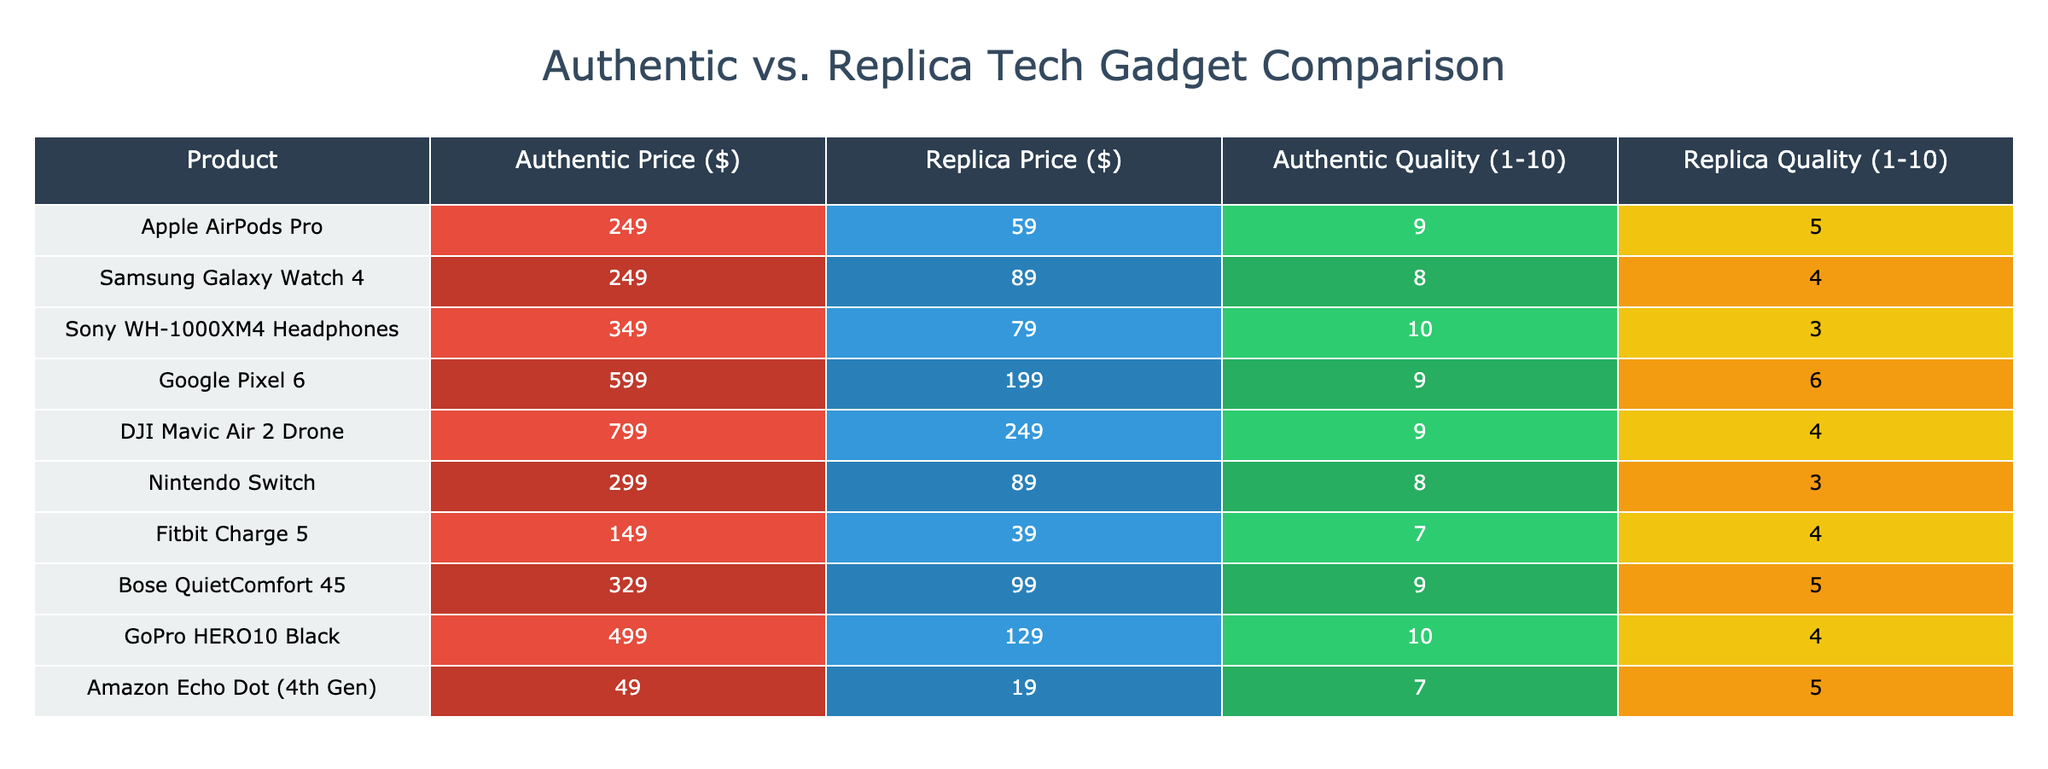What is the price difference between the authentic and replica Apple AirPods Pro? The authentic price is $249 and the replica price is $59. The difference is calculated as $249 - $59 = $190.
Answer: 190 Which product has the highest quality rating for the authentic version? The Sony WH-1000XM4 Headphones have the highest quality rating of 10 on the authentic scale.
Answer: Sony WH-1000XM4 Headphones Is the quality of the replica Google Pixel 6 better than that of the replica Fitbit Charge 5? The replica quality of Google Pixel 6 is rated 6, while the Fitbit Charge 5 is rated 4. Since 6 is greater than 4, the Google Pixel 6 has better quality than the Fitbit Charge 5.
Answer: Yes What is the average authentic price of all the products listed? To calculate the average, sum the authentic prices: 249 + 249 + 349 + 599 + 799 + 299 + 149 + 329 + 499 + 49 = 2,670. There are 10 products, so the average is 2,670 / 10 = 267.
Answer: 267 Are there any products where the authentic price is less than twice the replica price? To find this, we need to check each product's prices. Checking each pair: Apple AirPods Pro (249 vs 59), Samsung Galaxy Watch 4 (249 vs 89), Sony WH-1000XM4 (349 vs 79), Google Pixel 6 (599 vs 199), DJI Mavic Air 2 (799 vs 249), Nintendo Switch (299 vs 89), Fitbit Charge 5 (149 vs 39), Bose QuietComfort 45 (329 vs 99), GoPro HERO10 Black (499 vs 129), Amazon Echo Dot (49 vs 19). None meet the criteria where authentic is less than twice the replica, as all authentic prices are either equal to or more than double their replica counterpart.
Answer: No What is the total quality score for all the replica gadgets? Summing the replica quality scores gives: 5 + 4 + 3 + 6 + 4 + 3 + 4 + 5 + 4 + 5 = 43.
Answer: 43 Which authentic gadget has the lowest quality rating? Looking through the quality ratings for the authentic gadgets, the Nintendo Switch has the lowest rating of 8.
Answer: Nintendo Switch What percentage of the authentic products have a quality score of 9 or higher? There are 10 authentic products, and 5 of them have a quality score of 9 or above (Apple AirPods Pro, Sony WH-1000XM4, Google Pixel 6, Bose QuietComfort 45, GoPro HERO10). The percentage is then (5/10) * 100 = 50%.
Answer: 50% 